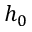Convert formula to latex. <formula><loc_0><loc_0><loc_500><loc_500>h _ { 0 }</formula> 